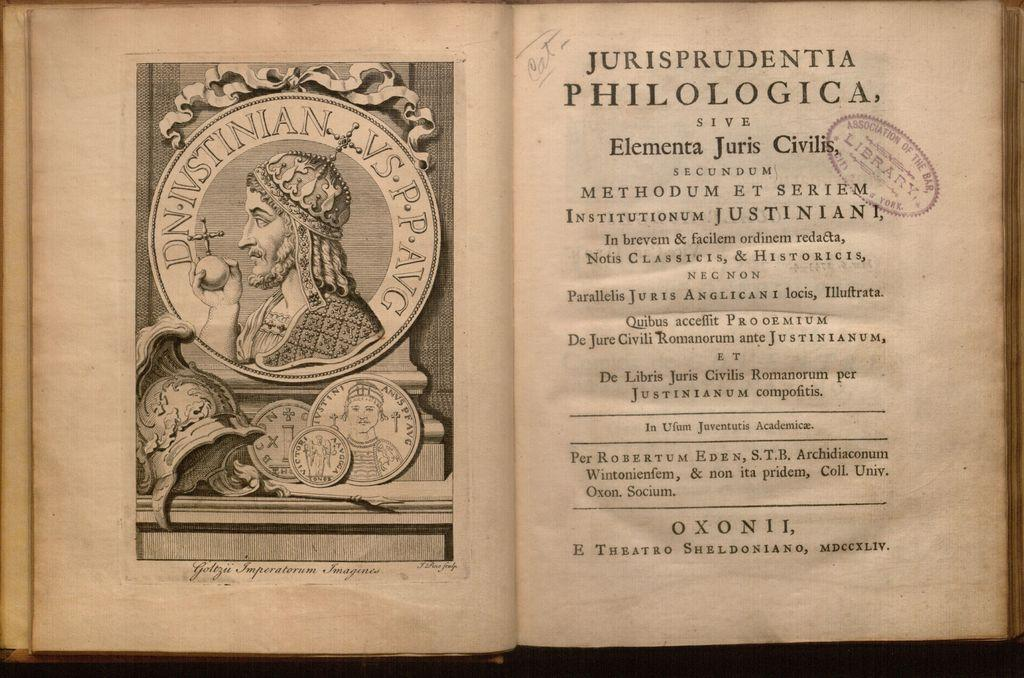Provide a one-sentence caption for the provided image. The word OxonII, can be seen at the bottom of this antique book. 